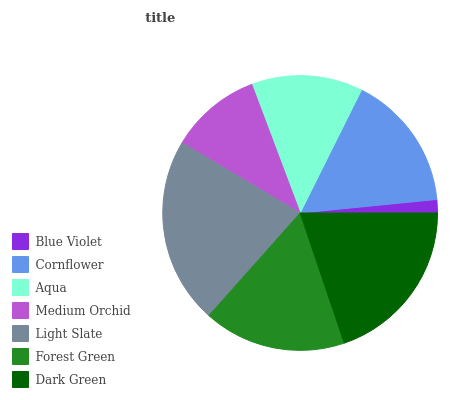Is Blue Violet the minimum?
Answer yes or no. Yes. Is Light Slate the maximum?
Answer yes or no. Yes. Is Cornflower the minimum?
Answer yes or no. No. Is Cornflower the maximum?
Answer yes or no. No. Is Cornflower greater than Blue Violet?
Answer yes or no. Yes. Is Blue Violet less than Cornflower?
Answer yes or no. Yes. Is Blue Violet greater than Cornflower?
Answer yes or no. No. Is Cornflower less than Blue Violet?
Answer yes or no. No. Is Cornflower the high median?
Answer yes or no. Yes. Is Cornflower the low median?
Answer yes or no. Yes. Is Light Slate the high median?
Answer yes or no. No. Is Blue Violet the low median?
Answer yes or no. No. 